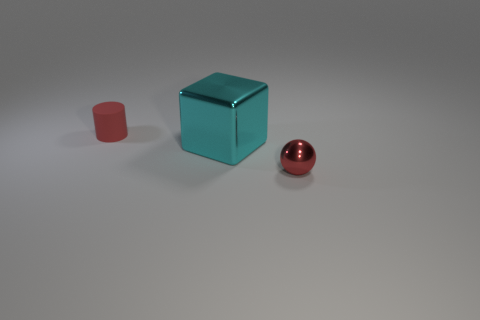Is there any other thing that is the same size as the metal cube?
Offer a very short reply. No. Is the cyan object the same size as the red sphere?
Offer a very short reply. No. Are there fewer cyan metal cubes on the left side of the large cyan shiny cube than big cyan metallic cubes that are in front of the cylinder?
Make the answer very short. Yes. How big is the object that is on the left side of the tiny red metal sphere and in front of the tiny red rubber thing?
Provide a succinct answer. Large. Are there any things that are in front of the red object behind the metallic thing to the right of the big metal block?
Make the answer very short. Yes. Are any cyan shiny spheres visible?
Provide a short and direct response. No. Is the number of tiny red things on the left side of the cyan metal cube greater than the number of red cylinders that are on the left side of the tiny rubber cylinder?
Your response must be concise. Yes. The ball that is the same material as the big cyan object is what size?
Provide a short and direct response. Small. There is a block in front of the red thing to the left of the small red thing that is on the right side of the big cube; what size is it?
Offer a very short reply. Large. The small thing to the right of the red matte thing is what color?
Offer a very short reply. Red. 